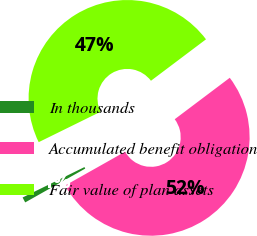<chart> <loc_0><loc_0><loc_500><loc_500><pie_chart><fcel>In thousands<fcel>Accumulated benefit obligation<fcel>Fair value of plan assets<nl><fcel>0.9%<fcel>52.1%<fcel>47.0%<nl></chart> 